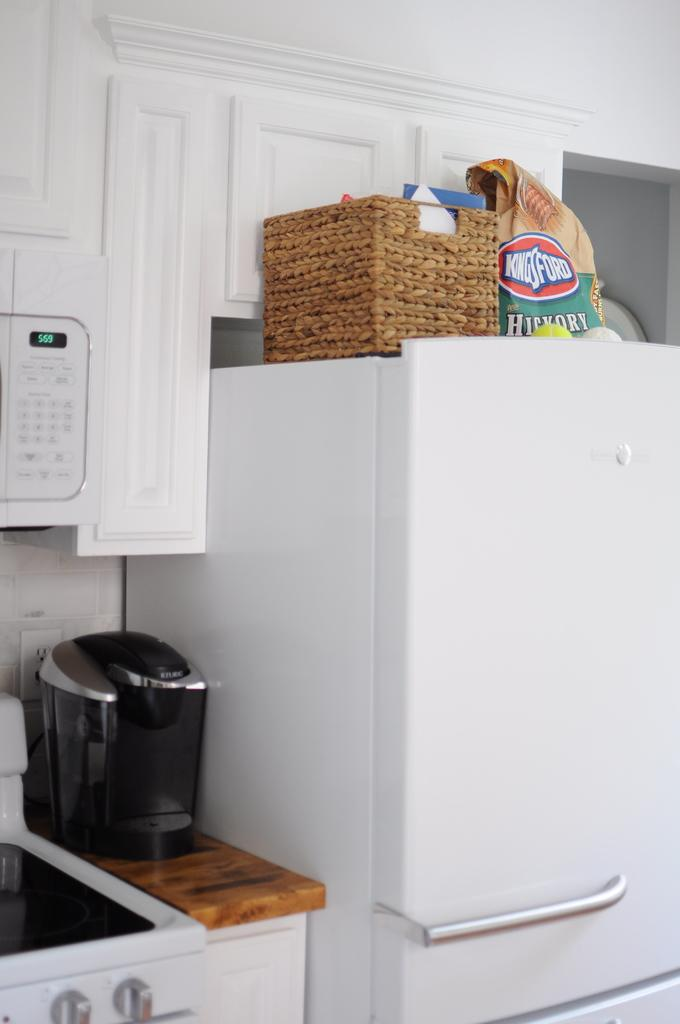Provide a one-sentence caption for the provided image. A kitchen filled with an oven, coffee maker, and charcol, among other things. 